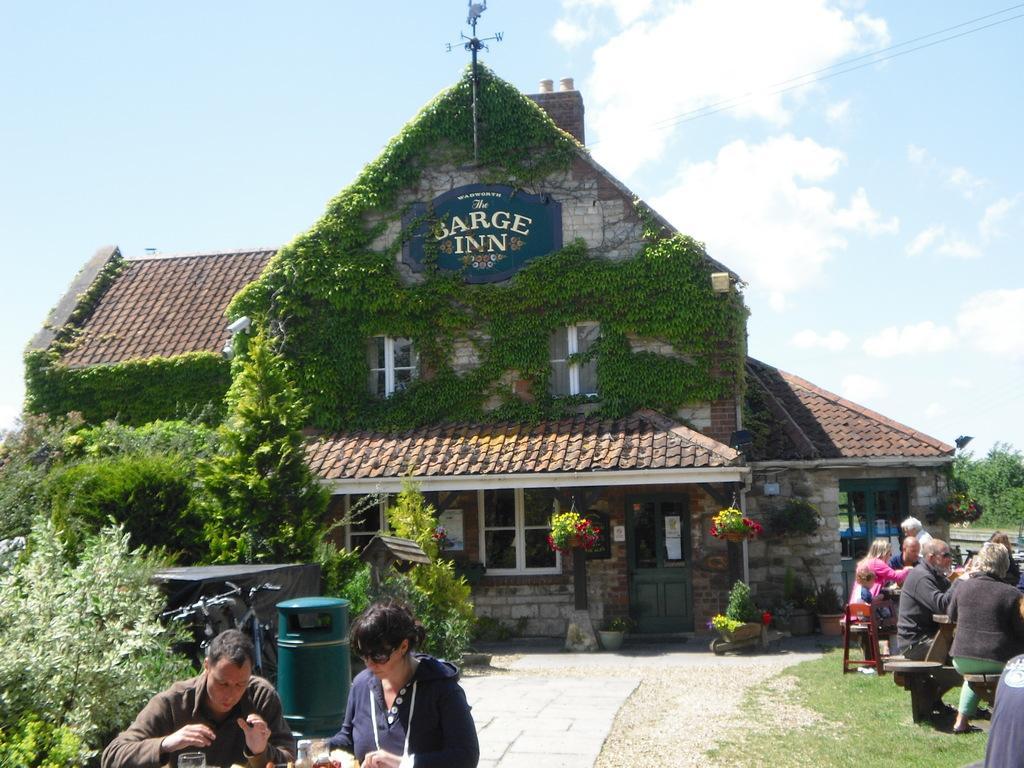How would you summarize this image in a sentence or two? In the picture I can see a house. On the house there is a board which has something written on it. I can also see people sitting on chairs. Here I can see trees, plants, the grass and some other objects on the ground. In the background I can see the sky. 